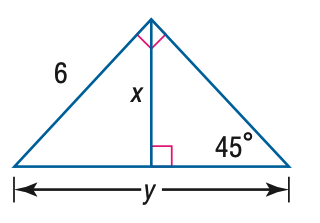Answer the mathemtical geometry problem and directly provide the correct option letter.
Question: Find x.
Choices: A: 3 B: 3 \sqrt { 2 } C: 3 \sqrt { 3 } D: 6 \sqrt { 2 } B 